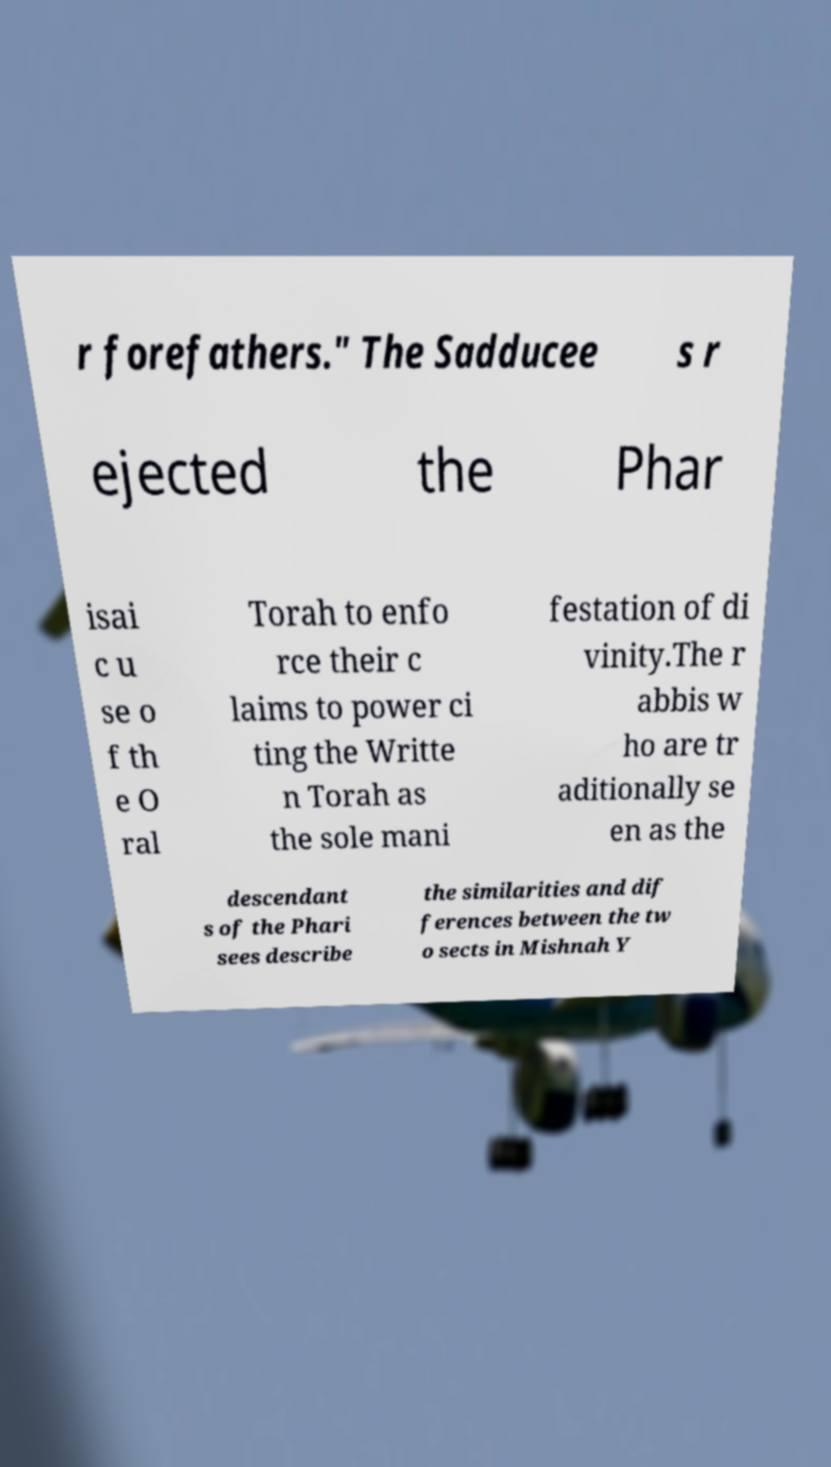Could you assist in decoding the text presented in this image and type it out clearly? r forefathers." The Sadducee s r ejected the Phar isai c u se o f th e O ral Torah to enfo rce their c laims to power ci ting the Writte n Torah as the sole mani festation of di vinity.The r abbis w ho are tr aditionally se en as the descendant s of the Phari sees describe the similarities and dif ferences between the tw o sects in Mishnah Y 